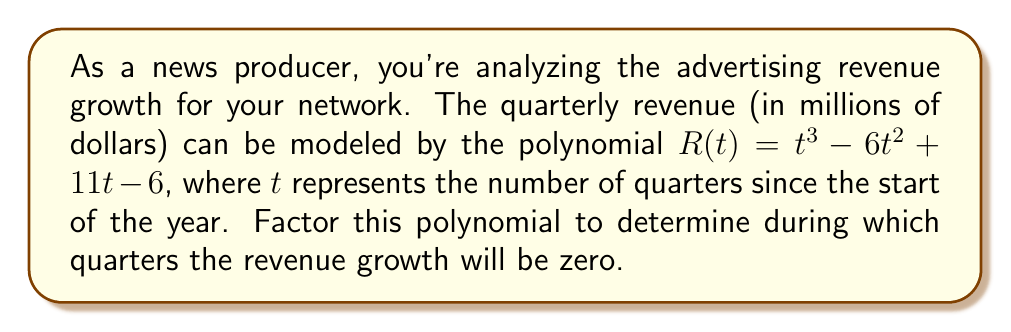Could you help me with this problem? To solve this problem, we need to factor the polynomial $R(t) = t^3 - 6t^2 + 11t - 6$ and find its roots. These roots will represent the quarters when the revenue growth is zero.

Step 1: Identify the polynomial
$R(t) = t^3 - 6t^2 + 11t - 6$

Step 2: Try to factor out the greatest common factor (GCF)
There is no common factor for all terms, so we proceed to the next step.

Step 3: Check if it's a perfect cube
It's not a perfect cube, so we'll use the rational root theorem.

Step 4: Use the rational root theorem
Possible rational roots are factors of the constant term (6): ±1, ±2, ±3, ±6

Step 5: Test these potential roots
We find that $t = 1$ is a root.

Step 6: Factor out $(t - 1)$
$R(t) = (t - 1)(t^2 - 5t + 6)$

Step 7: Factor the quadratic term
$t^2 - 5t + 6 = (t - 2)(t - 3)$

Step 8: Write the fully factored polynomial
$R(t) = (t - 1)(t - 2)(t - 3)$

The roots of this polynomial are $t = 1$, $t = 2$, and $t = 3$, corresponding to the 1st, 2nd, and 3rd quarters of the year.
Answer: 1st, 2nd, and 3rd quarters 